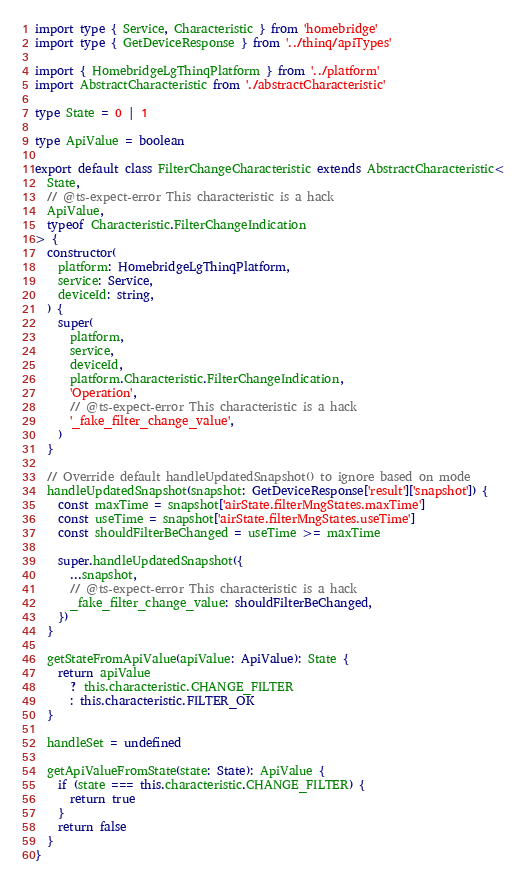Convert code to text. <code><loc_0><loc_0><loc_500><loc_500><_TypeScript_>import type { Service, Characteristic } from 'homebridge'
import type { GetDeviceResponse } from '../thinq/apiTypes'

import { HomebridgeLgThinqPlatform } from '../platform'
import AbstractCharacteristic from './abstractCharacteristic'

type State = 0 | 1

type ApiValue = boolean

export default class FilterChangeCharacteristic extends AbstractCharacteristic<
  State,
  // @ts-expect-error This characteristic is a hack
  ApiValue,
  typeof Characteristic.FilterChangeIndication
> {
  constructor(
    platform: HomebridgeLgThinqPlatform,
    service: Service,
    deviceId: string,
  ) {
    super(
      platform,
      service,
      deviceId,
      platform.Characteristic.FilterChangeIndication,
      'Operation',
      // @ts-expect-error This characteristic is a hack
      '_fake_filter_change_value',
    )
  }

  // Override default handleUpdatedSnapshot() to ignore based on mode
  handleUpdatedSnapshot(snapshot: GetDeviceResponse['result']['snapshot']) {
    const maxTime = snapshot['airState.filterMngStates.maxTime']
    const useTime = snapshot['airState.filterMngStates.useTime']
    const shouldFilterBeChanged = useTime >= maxTime

    super.handleUpdatedSnapshot({
      ...snapshot,
      // @ts-expect-error This characteristic is a hack
      _fake_filter_change_value: shouldFilterBeChanged,
    })
  }

  getStateFromApiValue(apiValue: ApiValue): State {
    return apiValue
      ? this.characteristic.CHANGE_FILTER
      : this.characteristic.FILTER_OK
  }

  handleSet = undefined

  getApiValueFromState(state: State): ApiValue {
    if (state === this.characteristic.CHANGE_FILTER) {
      return true
    }
    return false
  }
}
</code> 